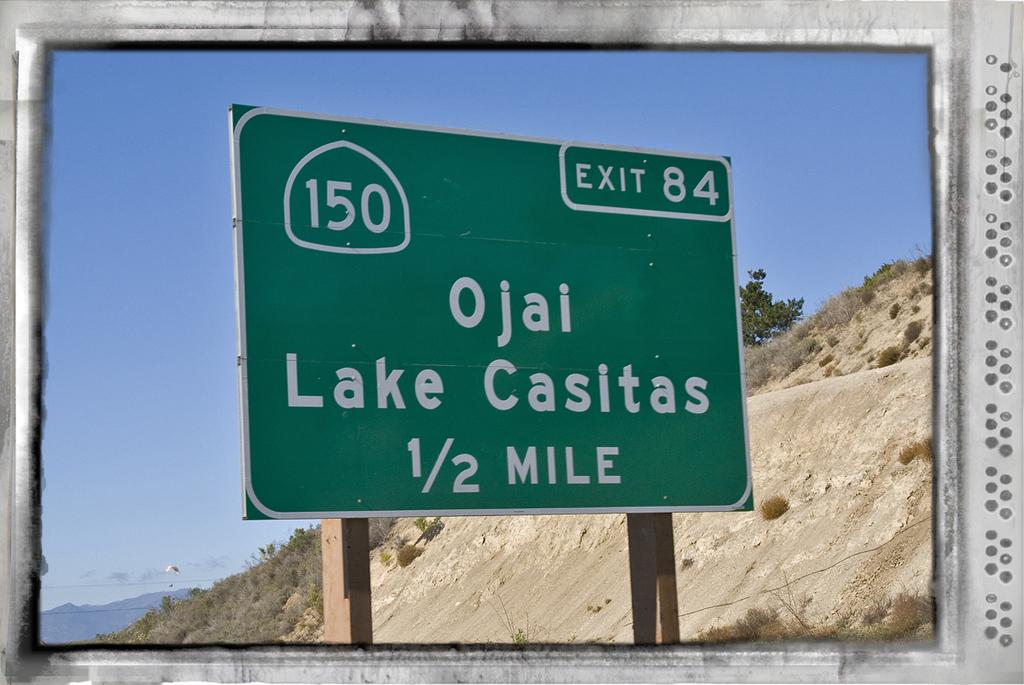<image>
Share a concise interpretation of the image provided. The road sign is for exit 84 to Ojai Lake Casitas in 1/2 mile. 